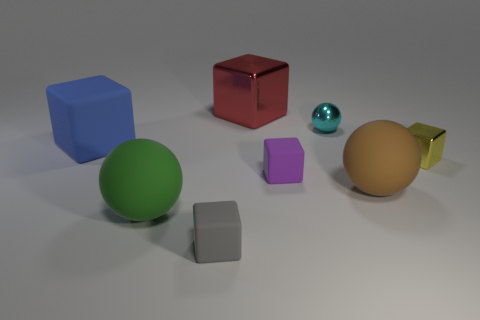Add 1 green rubber balls. How many objects exist? 9 Subtract all blue cubes. How many cubes are left? 4 Subtract all rubber balls. How many balls are left? 1 Subtract all balls. How many objects are left? 5 Subtract all yellow cubes. Subtract all yellow cylinders. How many cubes are left? 4 Add 1 yellow metal cubes. How many yellow metal cubes are left? 2 Add 2 brown spheres. How many brown spheres exist? 3 Subtract 0 yellow balls. How many objects are left? 8 Subtract all small purple shiny cylinders. Subtract all small purple matte objects. How many objects are left? 7 